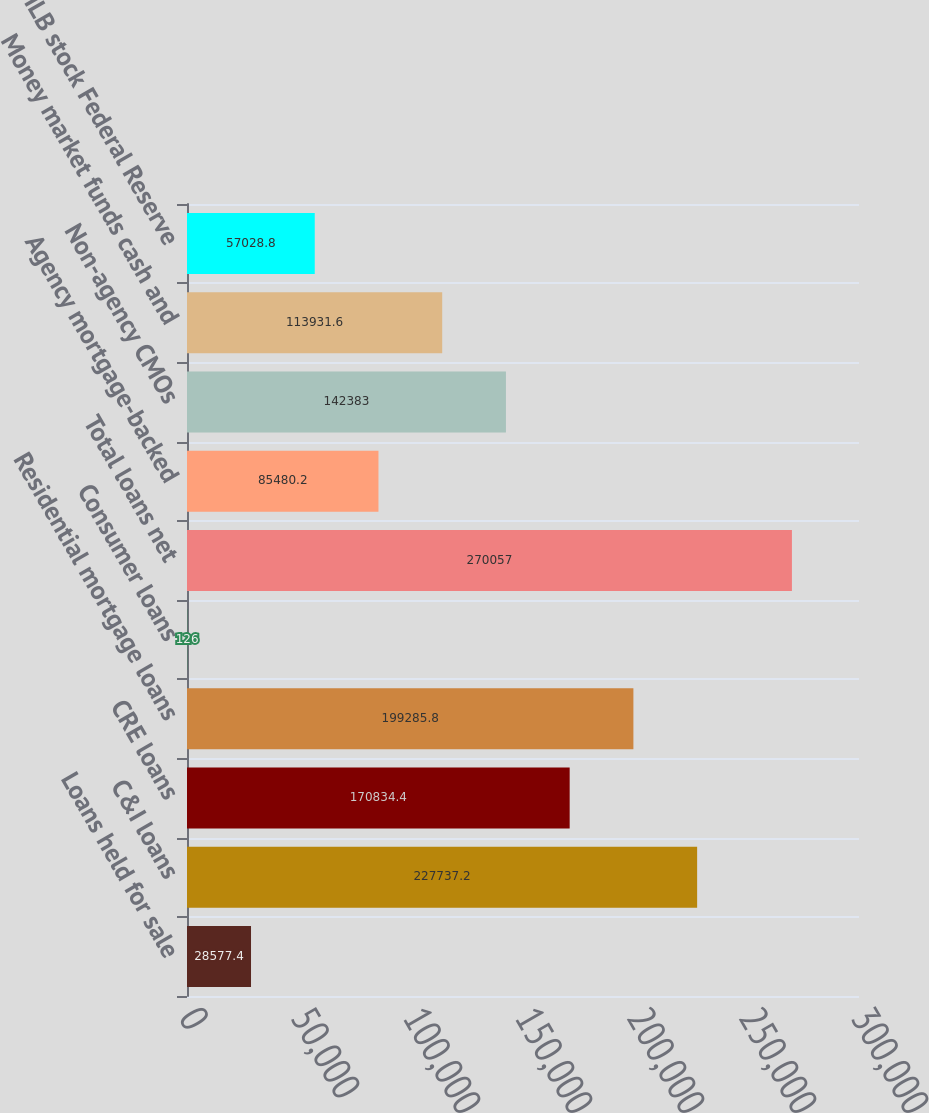Convert chart. <chart><loc_0><loc_0><loc_500><loc_500><bar_chart><fcel>Loans held for sale<fcel>C&I loans<fcel>CRE loans<fcel>Residential mortgage loans<fcel>Consumer loans<fcel>Total loans net<fcel>Agency mortgage-backed<fcel>Non-agency CMOs<fcel>Money market funds cash and<fcel>FHLB stock Federal Reserve<nl><fcel>28577.4<fcel>227737<fcel>170834<fcel>199286<fcel>126<fcel>270057<fcel>85480.2<fcel>142383<fcel>113932<fcel>57028.8<nl></chart> 